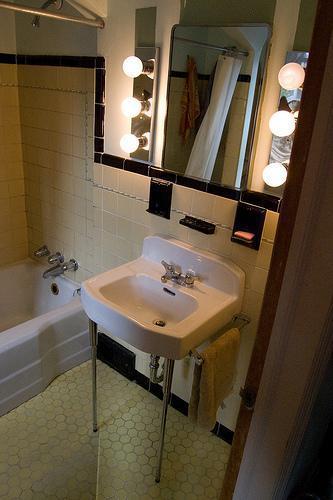How many sinks are there?
Give a very brief answer. 1. 